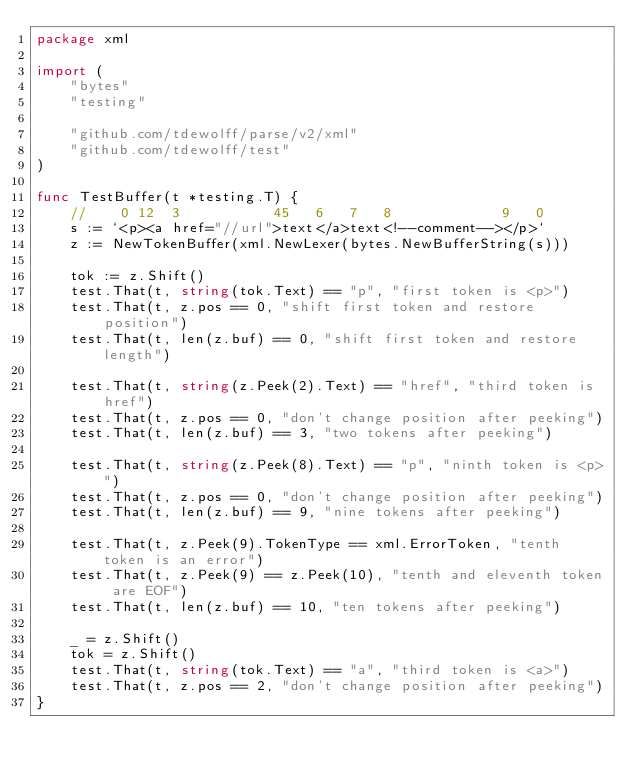Convert code to text. <code><loc_0><loc_0><loc_500><loc_500><_Go_>package xml

import (
	"bytes"
	"testing"

	"github.com/tdewolff/parse/v2/xml"
	"github.com/tdewolff/test"
)

func TestBuffer(t *testing.T) {
	//    0 12  3           45   6   7   8             9   0
	s := `<p><a href="//url">text</a>text<!--comment--></p>`
	z := NewTokenBuffer(xml.NewLexer(bytes.NewBufferString(s)))

	tok := z.Shift()
	test.That(t, string(tok.Text) == "p", "first token is <p>")
	test.That(t, z.pos == 0, "shift first token and restore position")
	test.That(t, len(z.buf) == 0, "shift first token and restore length")

	test.That(t, string(z.Peek(2).Text) == "href", "third token is href")
	test.That(t, z.pos == 0, "don't change position after peeking")
	test.That(t, len(z.buf) == 3, "two tokens after peeking")

	test.That(t, string(z.Peek(8).Text) == "p", "ninth token is <p>")
	test.That(t, z.pos == 0, "don't change position after peeking")
	test.That(t, len(z.buf) == 9, "nine tokens after peeking")

	test.That(t, z.Peek(9).TokenType == xml.ErrorToken, "tenth token is an error")
	test.That(t, z.Peek(9) == z.Peek(10), "tenth and eleventh token are EOF")
	test.That(t, len(z.buf) == 10, "ten tokens after peeking")

	_ = z.Shift()
	tok = z.Shift()
	test.That(t, string(tok.Text) == "a", "third token is <a>")
	test.That(t, z.pos == 2, "don't change position after peeking")
}
</code> 